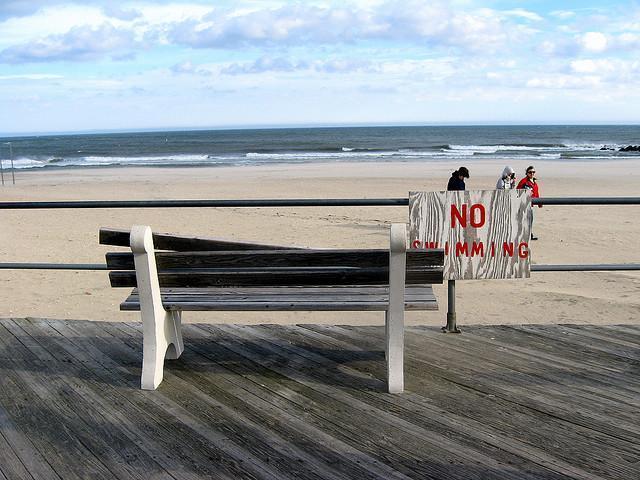How many people have their head covered?
Give a very brief answer. 2. 